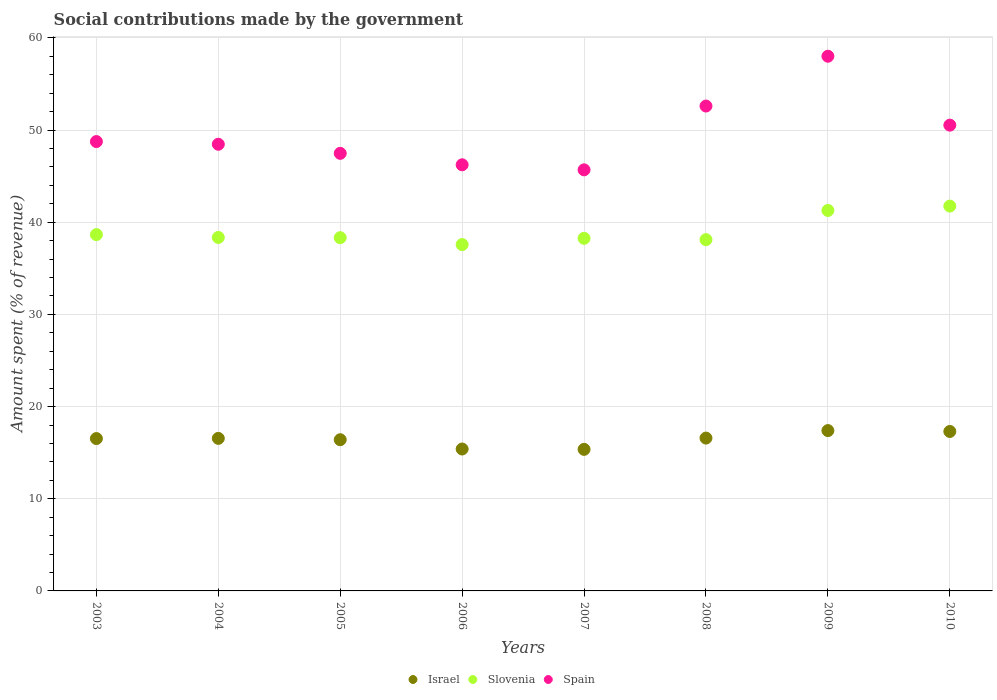How many different coloured dotlines are there?
Your answer should be compact. 3. What is the amount spent (in %) on social contributions in Spain in 2009?
Offer a very short reply. 58.01. Across all years, what is the maximum amount spent (in %) on social contributions in Spain?
Provide a short and direct response. 58.01. Across all years, what is the minimum amount spent (in %) on social contributions in Spain?
Provide a short and direct response. 45.69. What is the total amount spent (in %) on social contributions in Israel in the graph?
Make the answer very short. 131.52. What is the difference between the amount spent (in %) on social contributions in Spain in 2005 and that in 2007?
Your response must be concise. 1.79. What is the difference between the amount spent (in %) on social contributions in Spain in 2005 and the amount spent (in %) on social contributions in Israel in 2007?
Keep it short and to the point. 32.12. What is the average amount spent (in %) on social contributions in Spain per year?
Give a very brief answer. 49.72. In the year 2009, what is the difference between the amount spent (in %) on social contributions in Slovenia and amount spent (in %) on social contributions in Spain?
Offer a terse response. -16.73. What is the ratio of the amount spent (in %) on social contributions in Slovenia in 2005 to that in 2006?
Give a very brief answer. 1.02. Is the amount spent (in %) on social contributions in Slovenia in 2006 less than that in 2007?
Make the answer very short. Yes. What is the difference between the highest and the second highest amount spent (in %) on social contributions in Slovenia?
Keep it short and to the point. 0.47. What is the difference between the highest and the lowest amount spent (in %) on social contributions in Slovenia?
Make the answer very short. 4.18. Is the sum of the amount spent (in %) on social contributions in Spain in 2004 and 2006 greater than the maximum amount spent (in %) on social contributions in Israel across all years?
Keep it short and to the point. Yes. Is it the case that in every year, the sum of the amount spent (in %) on social contributions in Spain and amount spent (in %) on social contributions in Israel  is greater than the amount spent (in %) on social contributions in Slovenia?
Make the answer very short. Yes. How many dotlines are there?
Ensure brevity in your answer.  3. Does the graph contain any zero values?
Make the answer very short. No. Does the graph contain grids?
Your answer should be very brief. Yes. How many legend labels are there?
Give a very brief answer. 3. How are the legend labels stacked?
Provide a short and direct response. Horizontal. What is the title of the graph?
Provide a succinct answer. Social contributions made by the government. What is the label or title of the Y-axis?
Offer a terse response. Amount spent (% of revenue). What is the Amount spent (% of revenue) of Israel in 2003?
Ensure brevity in your answer.  16.53. What is the Amount spent (% of revenue) in Slovenia in 2003?
Offer a terse response. 38.66. What is the Amount spent (% of revenue) in Spain in 2003?
Give a very brief answer. 48.75. What is the Amount spent (% of revenue) in Israel in 2004?
Your response must be concise. 16.55. What is the Amount spent (% of revenue) in Slovenia in 2004?
Offer a very short reply. 38.35. What is the Amount spent (% of revenue) in Spain in 2004?
Provide a succinct answer. 48.46. What is the Amount spent (% of revenue) in Israel in 2005?
Your response must be concise. 16.41. What is the Amount spent (% of revenue) in Slovenia in 2005?
Your answer should be compact. 38.33. What is the Amount spent (% of revenue) of Spain in 2005?
Give a very brief answer. 47.48. What is the Amount spent (% of revenue) of Israel in 2006?
Provide a short and direct response. 15.4. What is the Amount spent (% of revenue) of Slovenia in 2006?
Offer a terse response. 37.58. What is the Amount spent (% of revenue) in Spain in 2006?
Your answer should be compact. 46.23. What is the Amount spent (% of revenue) of Israel in 2007?
Offer a very short reply. 15.36. What is the Amount spent (% of revenue) in Slovenia in 2007?
Make the answer very short. 38.26. What is the Amount spent (% of revenue) in Spain in 2007?
Your answer should be very brief. 45.69. What is the Amount spent (% of revenue) in Israel in 2008?
Offer a terse response. 16.58. What is the Amount spent (% of revenue) in Slovenia in 2008?
Offer a very short reply. 38.11. What is the Amount spent (% of revenue) of Spain in 2008?
Your answer should be compact. 52.61. What is the Amount spent (% of revenue) in Israel in 2009?
Make the answer very short. 17.4. What is the Amount spent (% of revenue) in Slovenia in 2009?
Provide a succinct answer. 41.28. What is the Amount spent (% of revenue) of Spain in 2009?
Offer a terse response. 58.01. What is the Amount spent (% of revenue) in Israel in 2010?
Your answer should be very brief. 17.3. What is the Amount spent (% of revenue) of Slovenia in 2010?
Make the answer very short. 41.75. What is the Amount spent (% of revenue) of Spain in 2010?
Make the answer very short. 50.53. Across all years, what is the maximum Amount spent (% of revenue) of Israel?
Your answer should be very brief. 17.4. Across all years, what is the maximum Amount spent (% of revenue) of Slovenia?
Give a very brief answer. 41.75. Across all years, what is the maximum Amount spent (% of revenue) in Spain?
Make the answer very short. 58.01. Across all years, what is the minimum Amount spent (% of revenue) in Israel?
Make the answer very short. 15.36. Across all years, what is the minimum Amount spent (% of revenue) in Slovenia?
Your response must be concise. 37.58. Across all years, what is the minimum Amount spent (% of revenue) of Spain?
Your answer should be very brief. 45.69. What is the total Amount spent (% of revenue) of Israel in the graph?
Provide a short and direct response. 131.52. What is the total Amount spent (% of revenue) in Slovenia in the graph?
Offer a very short reply. 312.31. What is the total Amount spent (% of revenue) of Spain in the graph?
Provide a short and direct response. 397.77. What is the difference between the Amount spent (% of revenue) in Israel in 2003 and that in 2004?
Offer a very short reply. -0.02. What is the difference between the Amount spent (% of revenue) in Slovenia in 2003 and that in 2004?
Offer a terse response. 0.31. What is the difference between the Amount spent (% of revenue) in Spain in 2003 and that in 2004?
Provide a succinct answer. 0.29. What is the difference between the Amount spent (% of revenue) in Israel in 2003 and that in 2005?
Offer a very short reply. 0.12. What is the difference between the Amount spent (% of revenue) of Slovenia in 2003 and that in 2005?
Your answer should be very brief. 0.33. What is the difference between the Amount spent (% of revenue) in Spain in 2003 and that in 2005?
Your answer should be compact. 1.28. What is the difference between the Amount spent (% of revenue) of Israel in 2003 and that in 2006?
Give a very brief answer. 1.13. What is the difference between the Amount spent (% of revenue) in Slovenia in 2003 and that in 2006?
Ensure brevity in your answer.  1.08. What is the difference between the Amount spent (% of revenue) in Spain in 2003 and that in 2006?
Give a very brief answer. 2.52. What is the difference between the Amount spent (% of revenue) of Israel in 2003 and that in 2007?
Keep it short and to the point. 1.17. What is the difference between the Amount spent (% of revenue) of Slovenia in 2003 and that in 2007?
Your answer should be compact. 0.4. What is the difference between the Amount spent (% of revenue) in Spain in 2003 and that in 2007?
Your answer should be very brief. 3.07. What is the difference between the Amount spent (% of revenue) of Israel in 2003 and that in 2008?
Your answer should be very brief. -0.05. What is the difference between the Amount spent (% of revenue) in Slovenia in 2003 and that in 2008?
Make the answer very short. 0.55. What is the difference between the Amount spent (% of revenue) of Spain in 2003 and that in 2008?
Make the answer very short. -3.85. What is the difference between the Amount spent (% of revenue) of Israel in 2003 and that in 2009?
Offer a very short reply. -0.87. What is the difference between the Amount spent (% of revenue) of Slovenia in 2003 and that in 2009?
Offer a very short reply. -2.62. What is the difference between the Amount spent (% of revenue) of Spain in 2003 and that in 2009?
Your answer should be very brief. -9.26. What is the difference between the Amount spent (% of revenue) in Israel in 2003 and that in 2010?
Offer a very short reply. -0.77. What is the difference between the Amount spent (% of revenue) in Slovenia in 2003 and that in 2010?
Give a very brief answer. -3.09. What is the difference between the Amount spent (% of revenue) in Spain in 2003 and that in 2010?
Make the answer very short. -1.78. What is the difference between the Amount spent (% of revenue) of Israel in 2004 and that in 2005?
Give a very brief answer. 0.15. What is the difference between the Amount spent (% of revenue) of Slovenia in 2004 and that in 2005?
Your answer should be compact. 0.02. What is the difference between the Amount spent (% of revenue) of Spain in 2004 and that in 2005?
Provide a succinct answer. 0.99. What is the difference between the Amount spent (% of revenue) of Israel in 2004 and that in 2006?
Give a very brief answer. 1.15. What is the difference between the Amount spent (% of revenue) in Slovenia in 2004 and that in 2006?
Make the answer very short. 0.78. What is the difference between the Amount spent (% of revenue) of Spain in 2004 and that in 2006?
Give a very brief answer. 2.23. What is the difference between the Amount spent (% of revenue) of Israel in 2004 and that in 2007?
Provide a short and direct response. 1.19. What is the difference between the Amount spent (% of revenue) of Slovenia in 2004 and that in 2007?
Provide a short and direct response. 0.1. What is the difference between the Amount spent (% of revenue) of Spain in 2004 and that in 2007?
Keep it short and to the point. 2.77. What is the difference between the Amount spent (% of revenue) in Israel in 2004 and that in 2008?
Your answer should be compact. -0.03. What is the difference between the Amount spent (% of revenue) of Slovenia in 2004 and that in 2008?
Offer a very short reply. 0.24. What is the difference between the Amount spent (% of revenue) of Spain in 2004 and that in 2008?
Offer a terse response. -4.15. What is the difference between the Amount spent (% of revenue) of Israel in 2004 and that in 2009?
Your answer should be compact. -0.84. What is the difference between the Amount spent (% of revenue) of Slovenia in 2004 and that in 2009?
Your answer should be compact. -2.93. What is the difference between the Amount spent (% of revenue) in Spain in 2004 and that in 2009?
Ensure brevity in your answer.  -9.55. What is the difference between the Amount spent (% of revenue) in Israel in 2004 and that in 2010?
Provide a succinct answer. -0.75. What is the difference between the Amount spent (% of revenue) of Slovenia in 2004 and that in 2010?
Provide a succinct answer. -3.4. What is the difference between the Amount spent (% of revenue) of Spain in 2004 and that in 2010?
Give a very brief answer. -2.07. What is the difference between the Amount spent (% of revenue) of Israel in 2005 and that in 2006?
Your answer should be compact. 1.01. What is the difference between the Amount spent (% of revenue) of Slovenia in 2005 and that in 2006?
Your response must be concise. 0.75. What is the difference between the Amount spent (% of revenue) of Spain in 2005 and that in 2006?
Offer a very short reply. 1.24. What is the difference between the Amount spent (% of revenue) of Israel in 2005 and that in 2007?
Your response must be concise. 1.05. What is the difference between the Amount spent (% of revenue) in Slovenia in 2005 and that in 2007?
Provide a short and direct response. 0.07. What is the difference between the Amount spent (% of revenue) of Spain in 2005 and that in 2007?
Offer a very short reply. 1.79. What is the difference between the Amount spent (% of revenue) of Israel in 2005 and that in 2008?
Ensure brevity in your answer.  -0.18. What is the difference between the Amount spent (% of revenue) in Slovenia in 2005 and that in 2008?
Your response must be concise. 0.21. What is the difference between the Amount spent (% of revenue) in Spain in 2005 and that in 2008?
Provide a short and direct response. -5.13. What is the difference between the Amount spent (% of revenue) in Israel in 2005 and that in 2009?
Give a very brief answer. -0.99. What is the difference between the Amount spent (% of revenue) in Slovenia in 2005 and that in 2009?
Provide a succinct answer. -2.95. What is the difference between the Amount spent (% of revenue) of Spain in 2005 and that in 2009?
Ensure brevity in your answer.  -10.54. What is the difference between the Amount spent (% of revenue) in Israel in 2005 and that in 2010?
Offer a very short reply. -0.89. What is the difference between the Amount spent (% of revenue) in Slovenia in 2005 and that in 2010?
Offer a terse response. -3.43. What is the difference between the Amount spent (% of revenue) in Spain in 2005 and that in 2010?
Your response must be concise. -3.06. What is the difference between the Amount spent (% of revenue) in Israel in 2006 and that in 2007?
Make the answer very short. 0.04. What is the difference between the Amount spent (% of revenue) in Slovenia in 2006 and that in 2007?
Your answer should be very brief. -0.68. What is the difference between the Amount spent (% of revenue) in Spain in 2006 and that in 2007?
Provide a succinct answer. 0.55. What is the difference between the Amount spent (% of revenue) in Israel in 2006 and that in 2008?
Provide a short and direct response. -1.18. What is the difference between the Amount spent (% of revenue) of Slovenia in 2006 and that in 2008?
Provide a short and direct response. -0.54. What is the difference between the Amount spent (% of revenue) of Spain in 2006 and that in 2008?
Make the answer very short. -6.37. What is the difference between the Amount spent (% of revenue) in Israel in 2006 and that in 2009?
Your answer should be very brief. -2. What is the difference between the Amount spent (% of revenue) of Slovenia in 2006 and that in 2009?
Give a very brief answer. -3.7. What is the difference between the Amount spent (% of revenue) of Spain in 2006 and that in 2009?
Offer a terse response. -11.78. What is the difference between the Amount spent (% of revenue) of Israel in 2006 and that in 2010?
Offer a very short reply. -1.9. What is the difference between the Amount spent (% of revenue) in Slovenia in 2006 and that in 2010?
Offer a very short reply. -4.18. What is the difference between the Amount spent (% of revenue) in Spain in 2006 and that in 2010?
Make the answer very short. -4.3. What is the difference between the Amount spent (% of revenue) in Israel in 2007 and that in 2008?
Your answer should be compact. -1.22. What is the difference between the Amount spent (% of revenue) of Slovenia in 2007 and that in 2008?
Provide a succinct answer. 0.14. What is the difference between the Amount spent (% of revenue) in Spain in 2007 and that in 2008?
Give a very brief answer. -6.92. What is the difference between the Amount spent (% of revenue) of Israel in 2007 and that in 2009?
Your answer should be very brief. -2.04. What is the difference between the Amount spent (% of revenue) of Slovenia in 2007 and that in 2009?
Offer a very short reply. -3.02. What is the difference between the Amount spent (% of revenue) of Spain in 2007 and that in 2009?
Provide a succinct answer. -12.33. What is the difference between the Amount spent (% of revenue) of Israel in 2007 and that in 2010?
Your answer should be very brief. -1.94. What is the difference between the Amount spent (% of revenue) of Slovenia in 2007 and that in 2010?
Offer a terse response. -3.5. What is the difference between the Amount spent (% of revenue) of Spain in 2007 and that in 2010?
Offer a very short reply. -4.85. What is the difference between the Amount spent (% of revenue) in Israel in 2008 and that in 2009?
Provide a succinct answer. -0.81. What is the difference between the Amount spent (% of revenue) in Slovenia in 2008 and that in 2009?
Ensure brevity in your answer.  -3.17. What is the difference between the Amount spent (% of revenue) in Spain in 2008 and that in 2009?
Offer a very short reply. -5.4. What is the difference between the Amount spent (% of revenue) in Israel in 2008 and that in 2010?
Your answer should be very brief. -0.72. What is the difference between the Amount spent (% of revenue) of Slovenia in 2008 and that in 2010?
Keep it short and to the point. -3.64. What is the difference between the Amount spent (% of revenue) in Spain in 2008 and that in 2010?
Your answer should be very brief. 2.07. What is the difference between the Amount spent (% of revenue) of Israel in 2009 and that in 2010?
Give a very brief answer. 0.1. What is the difference between the Amount spent (% of revenue) in Slovenia in 2009 and that in 2010?
Your answer should be very brief. -0.47. What is the difference between the Amount spent (% of revenue) in Spain in 2009 and that in 2010?
Your response must be concise. 7.48. What is the difference between the Amount spent (% of revenue) of Israel in 2003 and the Amount spent (% of revenue) of Slovenia in 2004?
Ensure brevity in your answer.  -21.82. What is the difference between the Amount spent (% of revenue) in Israel in 2003 and the Amount spent (% of revenue) in Spain in 2004?
Give a very brief answer. -31.93. What is the difference between the Amount spent (% of revenue) of Slovenia in 2003 and the Amount spent (% of revenue) of Spain in 2004?
Ensure brevity in your answer.  -9.8. What is the difference between the Amount spent (% of revenue) in Israel in 2003 and the Amount spent (% of revenue) in Slovenia in 2005?
Make the answer very short. -21.8. What is the difference between the Amount spent (% of revenue) in Israel in 2003 and the Amount spent (% of revenue) in Spain in 2005?
Offer a very short reply. -30.94. What is the difference between the Amount spent (% of revenue) of Slovenia in 2003 and the Amount spent (% of revenue) of Spain in 2005?
Give a very brief answer. -8.82. What is the difference between the Amount spent (% of revenue) in Israel in 2003 and the Amount spent (% of revenue) in Slovenia in 2006?
Provide a short and direct response. -21.05. What is the difference between the Amount spent (% of revenue) of Israel in 2003 and the Amount spent (% of revenue) of Spain in 2006?
Give a very brief answer. -29.7. What is the difference between the Amount spent (% of revenue) in Slovenia in 2003 and the Amount spent (% of revenue) in Spain in 2006?
Your answer should be compact. -7.58. What is the difference between the Amount spent (% of revenue) in Israel in 2003 and the Amount spent (% of revenue) in Slovenia in 2007?
Give a very brief answer. -21.73. What is the difference between the Amount spent (% of revenue) in Israel in 2003 and the Amount spent (% of revenue) in Spain in 2007?
Offer a very short reply. -29.16. What is the difference between the Amount spent (% of revenue) of Slovenia in 2003 and the Amount spent (% of revenue) of Spain in 2007?
Keep it short and to the point. -7.03. What is the difference between the Amount spent (% of revenue) of Israel in 2003 and the Amount spent (% of revenue) of Slovenia in 2008?
Provide a short and direct response. -21.58. What is the difference between the Amount spent (% of revenue) in Israel in 2003 and the Amount spent (% of revenue) in Spain in 2008?
Your response must be concise. -36.08. What is the difference between the Amount spent (% of revenue) of Slovenia in 2003 and the Amount spent (% of revenue) of Spain in 2008?
Keep it short and to the point. -13.95. What is the difference between the Amount spent (% of revenue) of Israel in 2003 and the Amount spent (% of revenue) of Slovenia in 2009?
Provide a succinct answer. -24.75. What is the difference between the Amount spent (% of revenue) of Israel in 2003 and the Amount spent (% of revenue) of Spain in 2009?
Make the answer very short. -41.48. What is the difference between the Amount spent (% of revenue) of Slovenia in 2003 and the Amount spent (% of revenue) of Spain in 2009?
Make the answer very short. -19.35. What is the difference between the Amount spent (% of revenue) in Israel in 2003 and the Amount spent (% of revenue) in Slovenia in 2010?
Your answer should be compact. -25.22. What is the difference between the Amount spent (% of revenue) of Israel in 2003 and the Amount spent (% of revenue) of Spain in 2010?
Offer a very short reply. -34. What is the difference between the Amount spent (% of revenue) of Slovenia in 2003 and the Amount spent (% of revenue) of Spain in 2010?
Make the answer very short. -11.88. What is the difference between the Amount spent (% of revenue) of Israel in 2004 and the Amount spent (% of revenue) of Slovenia in 2005?
Offer a terse response. -21.78. What is the difference between the Amount spent (% of revenue) of Israel in 2004 and the Amount spent (% of revenue) of Spain in 2005?
Give a very brief answer. -30.92. What is the difference between the Amount spent (% of revenue) in Slovenia in 2004 and the Amount spent (% of revenue) in Spain in 2005?
Provide a short and direct response. -9.12. What is the difference between the Amount spent (% of revenue) in Israel in 2004 and the Amount spent (% of revenue) in Slovenia in 2006?
Provide a succinct answer. -21.02. What is the difference between the Amount spent (% of revenue) of Israel in 2004 and the Amount spent (% of revenue) of Spain in 2006?
Ensure brevity in your answer.  -29.68. What is the difference between the Amount spent (% of revenue) of Slovenia in 2004 and the Amount spent (% of revenue) of Spain in 2006?
Provide a short and direct response. -7.88. What is the difference between the Amount spent (% of revenue) of Israel in 2004 and the Amount spent (% of revenue) of Slovenia in 2007?
Your answer should be very brief. -21.71. What is the difference between the Amount spent (% of revenue) in Israel in 2004 and the Amount spent (% of revenue) in Spain in 2007?
Your response must be concise. -29.14. What is the difference between the Amount spent (% of revenue) in Slovenia in 2004 and the Amount spent (% of revenue) in Spain in 2007?
Provide a short and direct response. -7.34. What is the difference between the Amount spent (% of revenue) of Israel in 2004 and the Amount spent (% of revenue) of Slovenia in 2008?
Make the answer very short. -21.56. What is the difference between the Amount spent (% of revenue) of Israel in 2004 and the Amount spent (% of revenue) of Spain in 2008?
Provide a short and direct response. -36.06. What is the difference between the Amount spent (% of revenue) in Slovenia in 2004 and the Amount spent (% of revenue) in Spain in 2008?
Give a very brief answer. -14.26. What is the difference between the Amount spent (% of revenue) in Israel in 2004 and the Amount spent (% of revenue) in Slovenia in 2009?
Provide a short and direct response. -24.73. What is the difference between the Amount spent (% of revenue) of Israel in 2004 and the Amount spent (% of revenue) of Spain in 2009?
Offer a terse response. -41.46. What is the difference between the Amount spent (% of revenue) in Slovenia in 2004 and the Amount spent (% of revenue) in Spain in 2009?
Your answer should be compact. -19.66. What is the difference between the Amount spent (% of revenue) in Israel in 2004 and the Amount spent (% of revenue) in Slovenia in 2010?
Ensure brevity in your answer.  -25.2. What is the difference between the Amount spent (% of revenue) of Israel in 2004 and the Amount spent (% of revenue) of Spain in 2010?
Offer a very short reply. -33.98. What is the difference between the Amount spent (% of revenue) in Slovenia in 2004 and the Amount spent (% of revenue) in Spain in 2010?
Keep it short and to the point. -12.18. What is the difference between the Amount spent (% of revenue) in Israel in 2005 and the Amount spent (% of revenue) in Slovenia in 2006?
Your answer should be very brief. -21.17. What is the difference between the Amount spent (% of revenue) in Israel in 2005 and the Amount spent (% of revenue) in Spain in 2006?
Provide a short and direct response. -29.83. What is the difference between the Amount spent (% of revenue) of Slovenia in 2005 and the Amount spent (% of revenue) of Spain in 2006?
Offer a very short reply. -7.91. What is the difference between the Amount spent (% of revenue) of Israel in 2005 and the Amount spent (% of revenue) of Slovenia in 2007?
Make the answer very short. -21.85. What is the difference between the Amount spent (% of revenue) in Israel in 2005 and the Amount spent (% of revenue) in Spain in 2007?
Give a very brief answer. -29.28. What is the difference between the Amount spent (% of revenue) of Slovenia in 2005 and the Amount spent (% of revenue) of Spain in 2007?
Give a very brief answer. -7.36. What is the difference between the Amount spent (% of revenue) of Israel in 2005 and the Amount spent (% of revenue) of Slovenia in 2008?
Offer a very short reply. -21.71. What is the difference between the Amount spent (% of revenue) in Israel in 2005 and the Amount spent (% of revenue) in Spain in 2008?
Provide a succinct answer. -36.2. What is the difference between the Amount spent (% of revenue) in Slovenia in 2005 and the Amount spent (% of revenue) in Spain in 2008?
Provide a succinct answer. -14.28. What is the difference between the Amount spent (% of revenue) in Israel in 2005 and the Amount spent (% of revenue) in Slovenia in 2009?
Ensure brevity in your answer.  -24.87. What is the difference between the Amount spent (% of revenue) in Israel in 2005 and the Amount spent (% of revenue) in Spain in 2009?
Provide a short and direct response. -41.61. What is the difference between the Amount spent (% of revenue) of Slovenia in 2005 and the Amount spent (% of revenue) of Spain in 2009?
Keep it short and to the point. -19.69. What is the difference between the Amount spent (% of revenue) of Israel in 2005 and the Amount spent (% of revenue) of Slovenia in 2010?
Make the answer very short. -25.35. What is the difference between the Amount spent (% of revenue) in Israel in 2005 and the Amount spent (% of revenue) in Spain in 2010?
Offer a terse response. -34.13. What is the difference between the Amount spent (% of revenue) in Slovenia in 2005 and the Amount spent (% of revenue) in Spain in 2010?
Offer a very short reply. -12.21. What is the difference between the Amount spent (% of revenue) of Israel in 2006 and the Amount spent (% of revenue) of Slovenia in 2007?
Ensure brevity in your answer.  -22.86. What is the difference between the Amount spent (% of revenue) of Israel in 2006 and the Amount spent (% of revenue) of Spain in 2007?
Your response must be concise. -30.29. What is the difference between the Amount spent (% of revenue) of Slovenia in 2006 and the Amount spent (% of revenue) of Spain in 2007?
Your response must be concise. -8.11. What is the difference between the Amount spent (% of revenue) in Israel in 2006 and the Amount spent (% of revenue) in Slovenia in 2008?
Make the answer very short. -22.71. What is the difference between the Amount spent (% of revenue) of Israel in 2006 and the Amount spent (% of revenue) of Spain in 2008?
Provide a succinct answer. -37.21. What is the difference between the Amount spent (% of revenue) in Slovenia in 2006 and the Amount spent (% of revenue) in Spain in 2008?
Offer a terse response. -15.03. What is the difference between the Amount spent (% of revenue) in Israel in 2006 and the Amount spent (% of revenue) in Slovenia in 2009?
Provide a succinct answer. -25.88. What is the difference between the Amount spent (% of revenue) in Israel in 2006 and the Amount spent (% of revenue) in Spain in 2009?
Give a very brief answer. -42.61. What is the difference between the Amount spent (% of revenue) of Slovenia in 2006 and the Amount spent (% of revenue) of Spain in 2009?
Make the answer very short. -20.44. What is the difference between the Amount spent (% of revenue) of Israel in 2006 and the Amount spent (% of revenue) of Slovenia in 2010?
Provide a short and direct response. -26.35. What is the difference between the Amount spent (% of revenue) of Israel in 2006 and the Amount spent (% of revenue) of Spain in 2010?
Offer a very short reply. -35.14. What is the difference between the Amount spent (% of revenue) of Slovenia in 2006 and the Amount spent (% of revenue) of Spain in 2010?
Your answer should be compact. -12.96. What is the difference between the Amount spent (% of revenue) in Israel in 2007 and the Amount spent (% of revenue) in Slovenia in 2008?
Your response must be concise. -22.75. What is the difference between the Amount spent (% of revenue) in Israel in 2007 and the Amount spent (% of revenue) in Spain in 2008?
Provide a short and direct response. -37.25. What is the difference between the Amount spent (% of revenue) in Slovenia in 2007 and the Amount spent (% of revenue) in Spain in 2008?
Offer a very short reply. -14.35. What is the difference between the Amount spent (% of revenue) of Israel in 2007 and the Amount spent (% of revenue) of Slovenia in 2009?
Provide a short and direct response. -25.92. What is the difference between the Amount spent (% of revenue) in Israel in 2007 and the Amount spent (% of revenue) in Spain in 2009?
Offer a terse response. -42.65. What is the difference between the Amount spent (% of revenue) in Slovenia in 2007 and the Amount spent (% of revenue) in Spain in 2009?
Provide a succinct answer. -19.76. What is the difference between the Amount spent (% of revenue) in Israel in 2007 and the Amount spent (% of revenue) in Slovenia in 2010?
Make the answer very short. -26.39. What is the difference between the Amount spent (% of revenue) in Israel in 2007 and the Amount spent (% of revenue) in Spain in 2010?
Your response must be concise. -35.18. What is the difference between the Amount spent (% of revenue) of Slovenia in 2007 and the Amount spent (% of revenue) of Spain in 2010?
Offer a very short reply. -12.28. What is the difference between the Amount spent (% of revenue) in Israel in 2008 and the Amount spent (% of revenue) in Slovenia in 2009?
Your response must be concise. -24.7. What is the difference between the Amount spent (% of revenue) of Israel in 2008 and the Amount spent (% of revenue) of Spain in 2009?
Offer a terse response. -41.43. What is the difference between the Amount spent (% of revenue) in Slovenia in 2008 and the Amount spent (% of revenue) in Spain in 2009?
Provide a succinct answer. -19.9. What is the difference between the Amount spent (% of revenue) of Israel in 2008 and the Amount spent (% of revenue) of Slovenia in 2010?
Your answer should be very brief. -25.17. What is the difference between the Amount spent (% of revenue) of Israel in 2008 and the Amount spent (% of revenue) of Spain in 2010?
Keep it short and to the point. -33.95. What is the difference between the Amount spent (% of revenue) in Slovenia in 2008 and the Amount spent (% of revenue) in Spain in 2010?
Your answer should be compact. -12.42. What is the difference between the Amount spent (% of revenue) of Israel in 2009 and the Amount spent (% of revenue) of Slovenia in 2010?
Offer a terse response. -24.36. What is the difference between the Amount spent (% of revenue) of Israel in 2009 and the Amount spent (% of revenue) of Spain in 2010?
Make the answer very short. -33.14. What is the difference between the Amount spent (% of revenue) in Slovenia in 2009 and the Amount spent (% of revenue) in Spain in 2010?
Your response must be concise. -9.26. What is the average Amount spent (% of revenue) in Israel per year?
Provide a succinct answer. 16.44. What is the average Amount spent (% of revenue) of Slovenia per year?
Provide a succinct answer. 39.04. What is the average Amount spent (% of revenue) in Spain per year?
Your answer should be compact. 49.72. In the year 2003, what is the difference between the Amount spent (% of revenue) in Israel and Amount spent (% of revenue) in Slovenia?
Offer a terse response. -22.13. In the year 2003, what is the difference between the Amount spent (% of revenue) in Israel and Amount spent (% of revenue) in Spain?
Offer a very short reply. -32.22. In the year 2003, what is the difference between the Amount spent (% of revenue) of Slovenia and Amount spent (% of revenue) of Spain?
Your answer should be very brief. -10.1. In the year 2004, what is the difference between the Amount spent (% of revenue) in Israel and Amount spent (% of revenue) in Slovenia?
Your answer should be compact. -21.8. In the year 2004, what is the difference between the Amount spent (% of revenue) of Israel and Amount spent (% of revenue) of Spain?
Provide a short and direct response. -31.91. In the year 2004, what is the difference between the Amount spent (% of revenue) of Slovenia and Amount spent (% of revenue) of Spain?
Your response must be concise. -10.11. In the year 2005, what is the difference between the Amount spent (% of revenue) of Israel and Amount spent (% of revenue) of Slovenia?
Provide a succinct answer. -21.92. In the year 2005, what is the difference between the Amount spent (% of revenue) of Israel and Amount spent (% of revenue) of Spain?
Provide a succinct answer. -31.07. In the year 2005, what is the difference between the Amount spent (% of revenue) of Slovenia and Amount spent (% of revenue) of Spain?
Provide a short and direct response. -9.15. In the year 2006, what is the difference between the Amount spent (% of revenue) of Israel and Amount spent (% of revenue) of Slovenia?
Give a very brief answer. -22.18. In the year 2006, what is the difference between the Amount spent (% of revenue) of Israel and Amount spent (% of revenue) of Spain?
Your response must be concise. -30.84. In the year 2006, what is the difference between the Amount spent (% of revenue) in Slovenia and Amount spent (% of revenue) in Spain?
Make the answer very short. -8.66. In the year 2007, what is the difference between the Amount spent (% of revenue) in Israel and Amount spent (% of revenue) in Slovenia?
Your answer should be very brief. -22.9. In the year 2007, what is the difference between the Amount spent (% of revenue) of Israel and Amount spent (% of revenue) of Spain?
Your answer should be very brief. -30.33. In the year 2007, what is the difference between the Amount spent (% of revenue) in Slovenia and Amount spent (% of revenue) in Spain?
Offer a terse response. -7.43. In the year 2008, what is the difference between the Amount spent (% of revenue) in Israel and Amount spent (% of revenue) in Slovenia?
Your answer should be very brief. -21.53. In the year 2008, what is the difference between the Amount spent (% of revenue) in Israel and Amount spent (% of revenue) in Spain?
Offer a very short reply. -36.03. In the year 2008, what is the difference between the Amount spent (% of revenue) of Slovenia and Amount spent (% of revenue) of Spain?
Give a very brief answer. -14.5. In the year 2009, what is the difference between the Amount spent (% of revenue) of Israel and Amount spent (% of revenue) of Slovenia?
Give a very brief answer. -23.88. In the year 2009, what is the difference between the Amount spent (% of revenue) of Israel and Amount spent (% of revenue) of Spain?
Your answer should be very brief. -40.62. In the year 2009, what is the difference between the Amount spent (% of revenue) in Slovenia and Amount spent (% of revenue) in Spain?
Provide a succinct answer. -16.73. In the year 2010, what is the difference between the Amount spent (% of revenue) in Israel and Amount spent (% of revenue) in Slovenia?
Your answer should be compact. -24.45. In the year 2010, what is the difference between the Amount spent (% of revenue) in Israel and Amount spent (% of revenue) in Spain?
Provide a short and direct response. -33.24. In the year 2010, what is the difference between the Amount spent (% of revenue) in Slovenia and Amount spent (% of revenue) in Spain?
Your answer should be compact. -8.78. What is the ratio of the Amount spent (% of revenue) of Israel in 2003 to that in 2004?
Give a very brief answer. 1. What is the ratio of the Amount spent (% of revenue) of Spain in 2003 to that in 2004?
Your response must be concise. 1.01. What is the ratio of the Amount spent (% of revenue) in Israel in 2003 to that in 2005?
Give a very brief answer. 1.01. What is the ratio of the Amount spent (% of revenue) of Slovenia in 2003 to that in 2005?
Offer a very short reply. 1.01. What is the ratio of the Amount spent (% of revenue) of Israel in 2003 to that in 2006?
Offer a very short reply. 1.07. What is the ratio of the Amount spent (% of revenue) of Slovenia in 2003 to that in 2006?
Provide a short and direct response. 1.03. What is the ratio of the Amount spent (% of revenue) in Spain in 2003 to that in 2006?
Make the answer very short. 1.05. What is the ratio of the Amount spent (% of revenue) of Israel in 2003 to that in 2007?
Your answer should be compact. 1.08. What is the ratio of the Amount spent (% of revenue) in Slovenia in 2003 to that in 2007?
Provide a succinct answer. 1.01. What is the ratio of the Amount spent (% of revenue) in Spain in 2003 to that in 2007?
Ensure brevity in your answer.  1.07. What is the ratio of the Amount spent (% of revenue) in Israel in 2003 to that in 2008?
Provide a succinct answer. 1. What is the ratio of the Amount spent (% of revenue) in Slovenia in 2003 to that in 2008?
Provide a succinct answer. 1.01. What is the ratio of the Amount spent (% of revenue) of Spain in 2003 to that in 2008?
Ensure brevity in your answer.  0.93. What is the ratio of the Amount spent (% of revenue) of Israel in 2003 to that in 2009?
Give a very brief answer. 0.95. What is the ratio of the Amount spent (% of revenue) in Slovenia in 2003 to that in 2009?
Offer a very short reply. 0.94. What is the ratio of the Amount spent (% of revenue) in Spain in 2003 to that in 2009?
Your answer should be very brief. 0.84. What is the ratio of the Amount spent (% of revenue) in Israel in 2003 to that in 2010?
Make the answer very short. 0.96. What is the ratio of the Amount spent (% of revenue) in Slovenia in 2003 to that in 2010?
Keep it short and to the point. 0.93. What is the ratio of the Amount spent (% of revenue) in Spain in 2003 to that in 2010?
Your answer should be very brief. 0.96. What is the ratio of the Amount spent (% of revenue) of Israel in 2004 to that in 2005?
Give a very brief answer. 1.01. What is the ratio of the Amount spent (% of revenue) of Spain in 2004 to that in 2005?
Provide a short and direct response. 1.02. What is the ratio of the Amount spent (% of revenue) in Israel in 2004 to that in 2006?
Provide a succinct answer. 1.07. What is the ratio of the Amount spent (% of revenue) of Slovenia in 2004 to that in 2006?
Ensure brevity in your answer.  1.02. What is the ratio of the Amount spent (% of revenue) of Spain in 2004 to that in 2006?
Offer a very short reply. 1.05. What is the ratio of the Amount spent (% of revenue) in Israel in 2004 to that in 2007?
Your response must be concise. 1.08. What is the ratio of the Amount spent (% of revenue) of Slovenia in 2004 to that in 2007?
Offer a very short reply. 1. What is the ratio of the Amount spent (% of revenue) of Spain in 2004 to that in 2007?
Your answer should be compact. 1.06. What is the ratio of the Amount spent (% of revenue) in Spain in 2004 to that in 2008?
Provide a short and direct response. 0.92. What is the ratio of the Amount spent (% of revenue) of Israel in 2004 to that in 2009?
Keep it short and to the point. 0.95. What is the ratio of the Amount spent (% of revenue) of Slovenia in 2004 to that in 2009?
Your answer should be very brief. 0.93. What is the ratio of the Amount spent (% of revenue) of Spain in 2004 to that in 2009?
Ensure brevity in your answer.  0.84. What is the ratio of the Amount spent (% of revenue) in Israel in 2004 to that in 2010?
Your answer should be very brief. 0.96. What is the ratio of the Amount spent (% of revenue) of Slovenia in 2004 to that in 2010?
Ensure brevity in your answer.  0.92. What is the ratio of the Amount spent (% of revenue) in Israel in 2005 to that in 2006?
Provide a succinct answer. 1.07. What is the ratio of the Amount spent (% of revenue) in Spain in 2005 to that in 2006?
Offer a very short reply. 1.03. What is the ratio of the Amount spent (% of revenue) of Israel in 2005 to that in 2007?
Offer a very short reply. 1.07. What is the ratio of the Amount spent (% of revenue) in Slovenia in 2005 to that in 2007?
Make the answer very short. 1. What is the ratio of the Amount spent (% of revenue) in Spain in 2005 to that in 2007?
Provide a short and direct response. 1.04. What is the ratio of the Amount spent (% of revenue) of Israel in 2005 to that in 2008?
Offer a very short reply. 0.99. What is the ratio of the Amount spent (% of revenue) in Slovenia in 2005 to that in 2008?
Ensure brevity in your answer.  1.01. What is the ratio of the Amount spent (% of revenue) in Spain in 2005 to that in 2008?
Provide a short and direct response. 0.9. What is the ratio of the Amount spent (% of revenue) in Israel in 2005 to that in 2009?
Make the answer very short. 0.94. What is the ratio of the Amount spent (% of revenue) in Slovenia in 2005 to that in 2009?
Your response must be concise. 0.93. What is the ratio of the Amount spent (% of revenue) of Spain in 2005 to that in 2009?
Your answer should be very brief. 0.82. What is the ratio of the Amount spent (% of revenue) in Israel in 2005 to that in 2010?
Provide a succinct answer. 0.95. What is the ratio of the Amount spent (% of revenue) of Slovenia in 2005 to that in 2010?
Keep it short and to the point. 0.92. What is the ratio of the Amount spent (% of revenue) of Spain in 2005 to that in 2010?
Provide a succinct answer. 0.94. What is the ratio of the Amount spent (% of revenue) of Israel in 2006 to that in 2007?
Give a very brief answer. 1. What is the ratio of the Amount spent (% of revenue) of Slovenia in 2006 to that in 2007?
Offer a terse response. 0.98. What is the ratio of the Amount spent (% of revenue) of Spain in 2006 to that in 2007?
Keep it short and to the point. 1.01. What is the ratio of the Amount spent (% of revenue) of Israel in 2006 to that in 2008?
Your response must be concise. 0.93. What is the ratio of the Amount spent (% of revenue) in Slovenia in 2006 to that in 2008?
Your response must be concise. 0.99. What is the ratio of the Amount spent (% of revenue) in Spain in 2006 to that in 2008?
Offer a very short reply. 0.88. What is the ratio of the Amount spent (% of revenue) of Israel in 2006 to that in 2009?
Offer a very short reply. 0.89. What is the ratio of the Amount spent (% of revenue) in Slovenia in 2006 to that in 2009?
Your answer should be very brief. 0.91. What is the ratio of the Amount spent (% of revenue) of Spain in 2006 to that in 2009?
Your response must be concise. 0.8. What is the ratio of the Amount spent (% of revenue) in Israel in 2006 to that in 2010?
Your answer should be very brief. 0.89. What is the ratio of the Amount spent (% of revenue) of Spain in 2006 to that in 2010?
Your answer should be very brief. 0.91. What is the ratio of the Amount spent (% of revenue) in Israel in 2007 to that in 2008?
Your answer should be compact. 0.93. What is the ratio of the Amount spent (% of revenue) in Slovenia in 2007 to that in 2008?
Keep it short and to the point. 1. What is the ratio of the Amount spent (% of revenue) in Spain in 2007 to that in 2008?
Give a very brief answer. 0.87. What is the ratio of the Amount spent (% of revenue) in Israel in 2007 to that in 2009?
Offer a very short reply. 0.88. What is the ratio of the Amount spent (% of revenue) in Slovenia in 2007 to that in 2009?
Provide a succinct answer. 0.93. What is the ratio of the Amount spent (% of revenue) in Spain in 2007 to that in 2009?
Offer a terse response. 0.79. What is the ratio of the Amount spent (% of revenue) of Israel in 2007 to that in 2010?
Make the answer very short. 0.89. What is the ratio of the Amount spent (% of revenue) of Slovenia in 2007 to that in 2010?
Provide a succinct answer. 0.92. What is the ratio of the Amount spent (% of revenue) in Spain in 2007 to that in 2010?
Your answer should be very brief. 0.9. What is the ratio of the Amount spent (% of revenue) of Israel in 2008 to that in 2009?
Ensure brevity in your answer.  0.95. What is the ratio of the Amount spent (% of revenue) in Slovenia in 2008 to that in 2009?
Keep it short and to the point. 0.92. What is the ratio of the Amount spent (% of revenue) in Spain in 2008 to that in 2009?
Ensure brevity in your answer.  0.91. What is the ratio of the Amount spent (% of revenue) in Israel in 2008 to that in 2010?
Keep it short and to the point. 0.96. What is the ratio of the Amount spent (% of revenue) in Slovenia in 2008 to that in 2010?
Give a very brief answer. 0.91. What is the ratio of the Amount spent (% of revenue) of Spain in 2008 to that in 2010?
Ensure brevity in your answer.  1.04. What is the ratio of the Amount spent (% of revenue) of Israel in 2009 to that in 2010?
Ensure brevity in your answer.  1.01. What is the ratio of the Amount spent (% of revenue) in Slovenia in 2009 to that in 2010?
Ensure brevity in your answer.  0.99. What is the ratio of the Amount spent (% of revenue) in Spain in 2009 to that in 2010?
Your response must be concise. 1.15. What is the difference between the highest and the second highest Amount spent (% of revenue) in Israel?
Offer a terse response. 0.1. What is the difference between the highest and the second highest Amount spent (% of revenue) in Slovenia?
Offer a very short reply. 0.47. What is the difference between the highest and the second highest Amount spent (% of revenue) in Spain?
Provide a succinct answer. 5.4. What is the difference between the highest and the lowest Amount spent (% of revenue) of Israel?
Offer a very short reply. 2.04. What is the difference between the highest and the lowest Amount spent (% of revenue) in Slovenia?
Provide a succinct answer. 4.18. What is the difference between the highest and the lowest Amount spent (% of revenue) of Spain?
Your answer should be very brief. 12.33. 